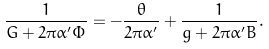<formula> <loc_0><loc_0><loc_500><loc_500>\frac { 1 } { G + 2 \pi \alpha ^ { \prime } \Phi } = - \frac { \theta } { 2 \pi \alpha ^ { \prime } } + \frac { 1 } { g + 2 \pi \alpha ^ { \prime } B } .</formula> 